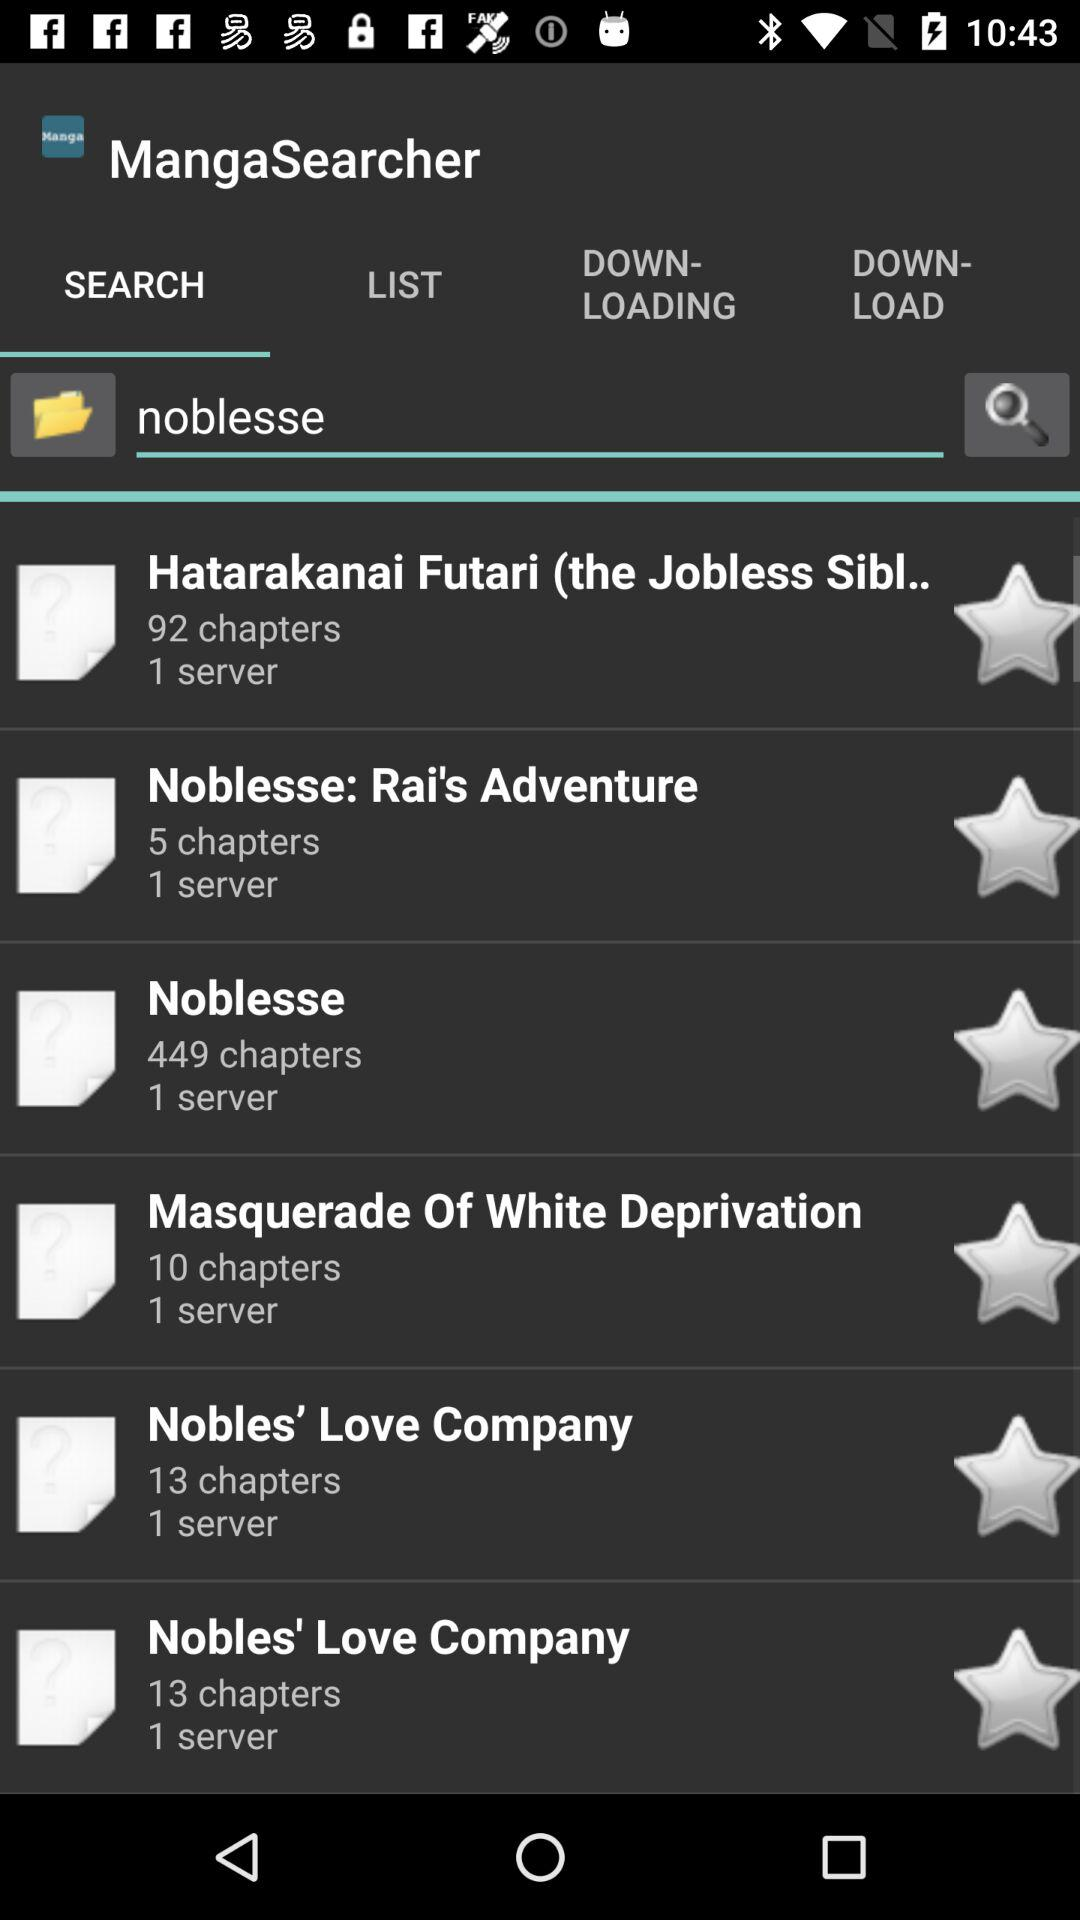Which book has five chapters? The book which has five chapters is "Noblesse: Rai's Adventure". 